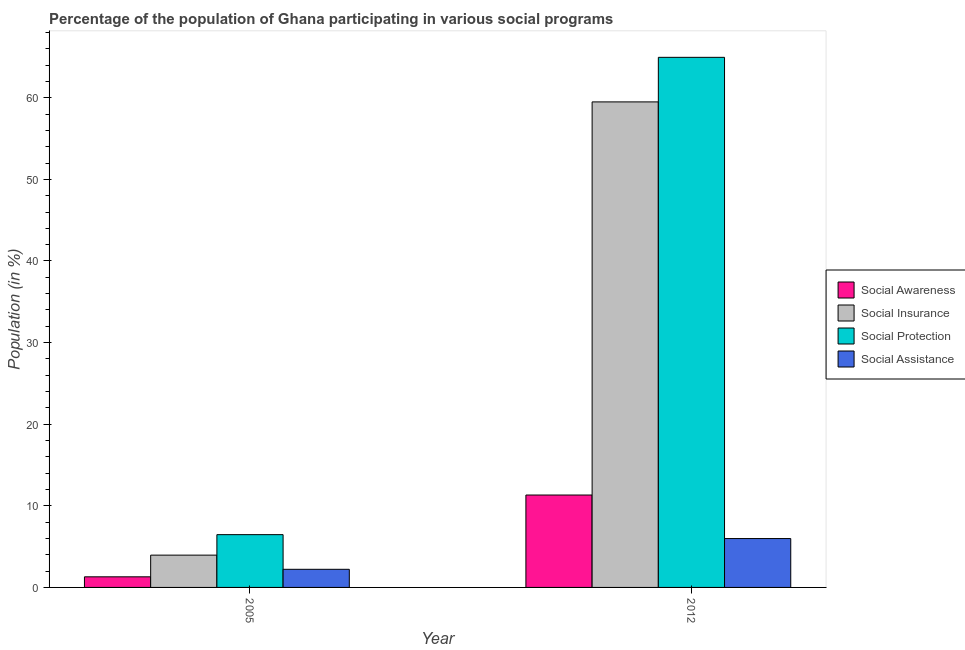How many groups of bars are there?
Provide a succinct answer. 2. Are the number of bars on each tick of the X-axis equal?
Your answer should be very brief. Yes. How many bars are there on the 2nd tick from the right?
Provide a succinct answer. 4. What is the label of the 1st group of bars from the left?
Offer a very short reply. 2005. What is the participation of population in social insurance programs in 2005?
Your answer should be very brief. 3.96. Across all years, what is the maximum participation of population in social assistance programs?
Offer a very short reply. 5.99. Across all years, what is the minimum participation of population in social insurance programs?
Your answer should be very brief. 3.96. In which year was the participation of population in social insurance programs maximum?
Offer a very short reply. 2012. In which year was the participation of population in social protection programs minimum?
Offer a very short reply. 2005. What is the total participation of population in social assistance programs in the graph?
Make the answer very short. 8.21. What is the difference between the participation of population in social awareness programs in 2005 and that in 2012?
Provide a short and direct response. -10.02. What is the difference between the participation of population in social awareness programs in 2005 and the participation of population in social assistance programs in 2012?
Provide a succinct answer. -10.02. What is the average participation of population in social protection programs per year?
Your answer should be compact. 35.71. In the year 2005, what is the difference between the participation of population in social insurance programs and participation of population in social protection programs?
Make the answer very short. 0. In how many years, is the participation of population in social assistance programs greater than 62 %?
Your answer should be very brief. 0. What is the ratio of the participation of population in social assistance programs in 2005 to that in 2012?
Your answer should be compact. 0.37. Is the participation of population in social protection programs in 2005 less than that in 2012?
Your answer should be very brief. Yes. What does the 1st bar from the left in 2005 represents?
Your response must be concise. Social Awareness. What does the 4th bar from the right in 2012 represents?
Ensure brevity in your answer.  Social Awareness. How many bars are there?
Your answer should be compact. 8. How many years are there in the graph?
Keep it short and to the point. 2. What is the difference between two consecutive major ticks on the Y-axis?
Make the answer very short. 10. Are the values on the major ticks of Y-axis written in scientific E-notation?
Your response must be concise. No. Where does the legend appear in the graph?
Your answer should be compact. Center right. What is the title of the graph?
Give a very brief answer. Percentage of the population of Ghana participating in various social programs . What is the label or title of the X-axis?
Keep it short and to the point. Year. What is the Population (in %) in Social Awareness in 2005?
Offer a terse response. 1.3. What is the Population (in %) of Social Insurance in 2005?
Offer a terse response. 3.96. What is the Population (in %) of Social Protection in 2005?
Give a very brief answer. 6.47. What is the Population (in %) of Social Assistance in 2005?
Offer a very short reply. 2.22. What is the Population (in %) of Social Awareness in 2012?
Your answer should be compact. 11.32. What is the Population (in %) in Social Insurance in 2012?
Your response must be concise. 59.49. What is the Population (in %) of Social Protection in 2012?
Your answer should be compact. 64.95. What is the Population (in %) of Social Assistance in 2012?
Your response must be concise. 5.99. Across all years, what is the maximum Population (in %) in Social Awareness?
Offer a terse response. 11.32. Across all years, what is the maximum Population (in %) of Social Insurance?
Provide a short and direct response. 59.49. Across all years, what is the maximum Population (in %) of Social Protection?
Ensure brevity in your answer.  64.95. Across all years, what is the maximum Population (in %) in Social Assistance?
Offer a very short reply. 5.99. Across all years, what is the minimum Population (in %) of Social Awareness?
Ensure brevity in your answer.  1.3. Across all years, what is the minimum Population (in %) of Social Insurance?
Your response must be concise. 3.96. Across all years, what is the minimum Population (in %) in Social Protection?
Keep it short and to the point. 6.47. Across all years, what is the minimum Population (in %) in Social Assistance?
Offer a terse response. 2.22. What is the total Population (in %) of Social Awareness in the graph?
Keep it short and to the point. 12.62. What is the total Population (in %) in Social Insurance in the graph?
Provide a short and direct response. 63.45. What is the total Population (in %) in Social Protection in the graph?
Make the answer very short. 71.42. What is the total Population (in %) in Social Assistance in the graph?
Offer a very short reply. 8.21. What is the difference between the Population (in %) in Social Awareness in 2005 and that in 2012?
Make the answer very short. -10.02. What is the difference between the Population (in %) in Social Insurance in 2005 and that in 2012?
Provide a short and direct response. -55.53. What is the difference between the Population (in %) in Social Protection in 2005 and that in 2012?
Your response must be concise. -58.48. What is the difference between the Population (in %) of Social Assistance in 2005 and that in 2012?
Give a very brief answer. -3.77. What is the difference between the Population (in %) in Social Awareness in 2005 and the Population (in %) in Social Insurance in 2012?
Make the answer very short. -58.19. What is the difference between the Population (in %) of Social Awareness in 2005 and the Population (in %) of Social Protection in 2012?
Offer a terse response. -63.65. What is the difference between the Population (in %) in Social Awareness in 2005 and the Population (in %) in Social Assistance in 2012?
Offer a terse response. -4.69. What is the difference between the Population (in %) of Social Insurance in 2005 and the Population (in %) of Social Protection in 2012?
Offer a very short reply. -61. What is the difference between the Population (in %) in Social Insurance in 2005 and the Population (in %) in Social Assistance in 2012?
Provide a succinct answer. -2.03. What is the difference between the Population (in %) in Social Protection in 2005 and the Population (in %) in Social Assistance in 2012?
Your response must be concise. 0.48. What is the average Population (in %) of Social Awareness per year?
Your answer should be very brief. 6.31. What is the average Population (in %) of Social Insurance per year?
Offer a very short reply. 31.72. What is the average Population (in %) of Social Protection per year?
Your response must be concise. 35.71. What is the average Population (in %) of Social Assistance per year?
Make the answer very short. 4.1. In the year 2005, what is the difference between the Population (in %) in Social Awareness and Population (in %) in Social Insurance?
Offer a terse response. -2.66. In the year 2005, what is the difference between the Population (in %) in Social Awareness and Population (in %) in Social Protection?
Your response must be concise. -5.17. In the year 2005, what is the difference between the Population (in %) in Social Awareness and Population (in %) in Social Assistance?
Give a very brief answer. -0.92. In the year 2005, what is the difference between the Population (in %) in Social Insurance and Population (in %) in Social Protection?
Make the answer very short. -2.51. In the year 2005, what is the difference between the Population (in %) in Social Insurance and Population (in %) in Social Assistance?
Give a very brief answer. 1.74. In the year 2005, what is the difference between the Population (in %) in Social Protection and Population (in %) in Social Assistance?
Your answer should be compact. 4.25. In the year 2012, what is the difference between the Population (in %) of Social Awareness and Population (in %) of Social Insurance?
Make the answer very short. -48.17. In the year 2012, what is the difference between the Population (in %) in Social Awareness and Population (in %) in Social Protection?
Ensure brevity in your answer.  -53.63. In the year 2012, what is the difference between the Population (in %) in Social Awareness and Population (in %) in Social Assistance?
Your answer should be very brief. 5.33. In the year 2012, what is the difference between the Population (in %) of Social Insurance and Population (in %) of Social Protection?
Your answer should be compact. -5.46. In the year 2012, what is the difference between the Population (in %) in Social Insurance and Population (in %) in Social Assistance?
Make the answer very short. 53.5. In the year 2012, what is the difference between the Population (in %) of Social Protection and Population (in %) of Social Assistance?
Offer a terse response. 58.96. What is the ratio of the Population (in %) in Social Awareness in 2005 to that in 2012?
Provide a short and direct response. 0.11. What is the ratio of the Population (in %) of Social Insurance in 2005 to that in 2012?
Your response must be concise. 0.07. What is the ratio of the Population (in %) of Social Protection in 2005 to that in 2012?
Ensure brevity in your answer.  0.1. What is the ratio of the Population (in %) in Social Assistance in 2005 to that in 2012?
Offer a terse response. 0.37. What is the difference between the highest and the second highest Population (in %) of Social Awareness?
Make the answer very short. 10.02. What is the difference between the highest and the second highest Population (in %) of Social Insurance?
Ensure brevity in your answer.  55.53. What is the difference between the highest and the second highest Population (in %) in Social Protection?
Offer a terse response. 58.48. What is the difference between the highest and the second highest Population (in %) of Social Assistance?
Offer a very short reply. 3.77. What is the difference between the highest and the lowest Population (in %) of Social Awareness?
Keep it short and to the point. 10.02. What is the difference between the highest and the lowest Population (in %) of Social Insurance?
Ensure brevity in your answer.  55.53. What is the difference between the highest and the lowest Population (in %) of Social Protection?
Your answer should be compact. 58.48. What is the difference between the highest and the lowest Population (in %) of Social Assistance?
Give a very brief answer. 3.77. 